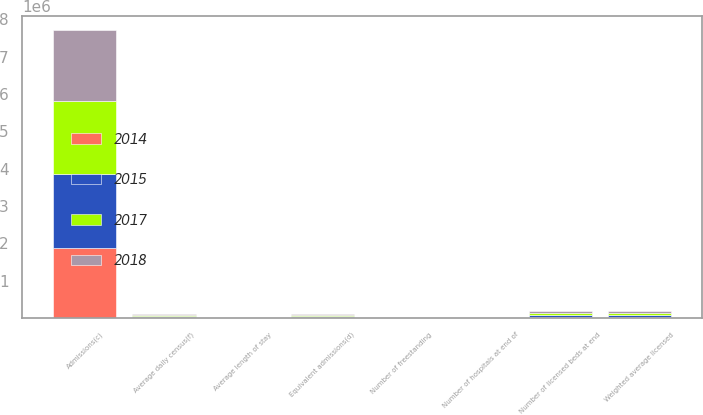Convert chart. <chart><loc_0><loc_0><loc_500><loc_500><stacked_bar_chart><ecel><fcel>Number of hospitals at end of<fcel>Number of freestanding<fcel>Number of licensed beds at end<fcel>Weighted average licensed<fcel>Admissions(c)<fcel>Equivalent admissions(d)<fcel>Average length of stay<fcel>Average daily census(f)<nl><fcel>2015<fcel>179<fcel>123<fcel>47199<fcel>46857<fcel>2.00375e+06<fcel>25670<fcel>4.9<fcel>26663<nl><fcel>2017<fcel>179<fcel>120<fcel>46738<fcel>45380<fcel>1.93661e+06<fcel>25670<fcel>4.9<fcel>26000<nl><fcel>2018<fcel>170<fcel>118<fcel>44290<fcel>44077<fcel>1.89183e+06<fcel>25670<fcel>4.9<fcel>25340<nl><fcel>2014<fcel>168<fcel>116<fcel>43771<fcel>43620<fcel>1.86879e+06<fcel>25670<fcel>4.9<fcel>25084<nl></chart> 